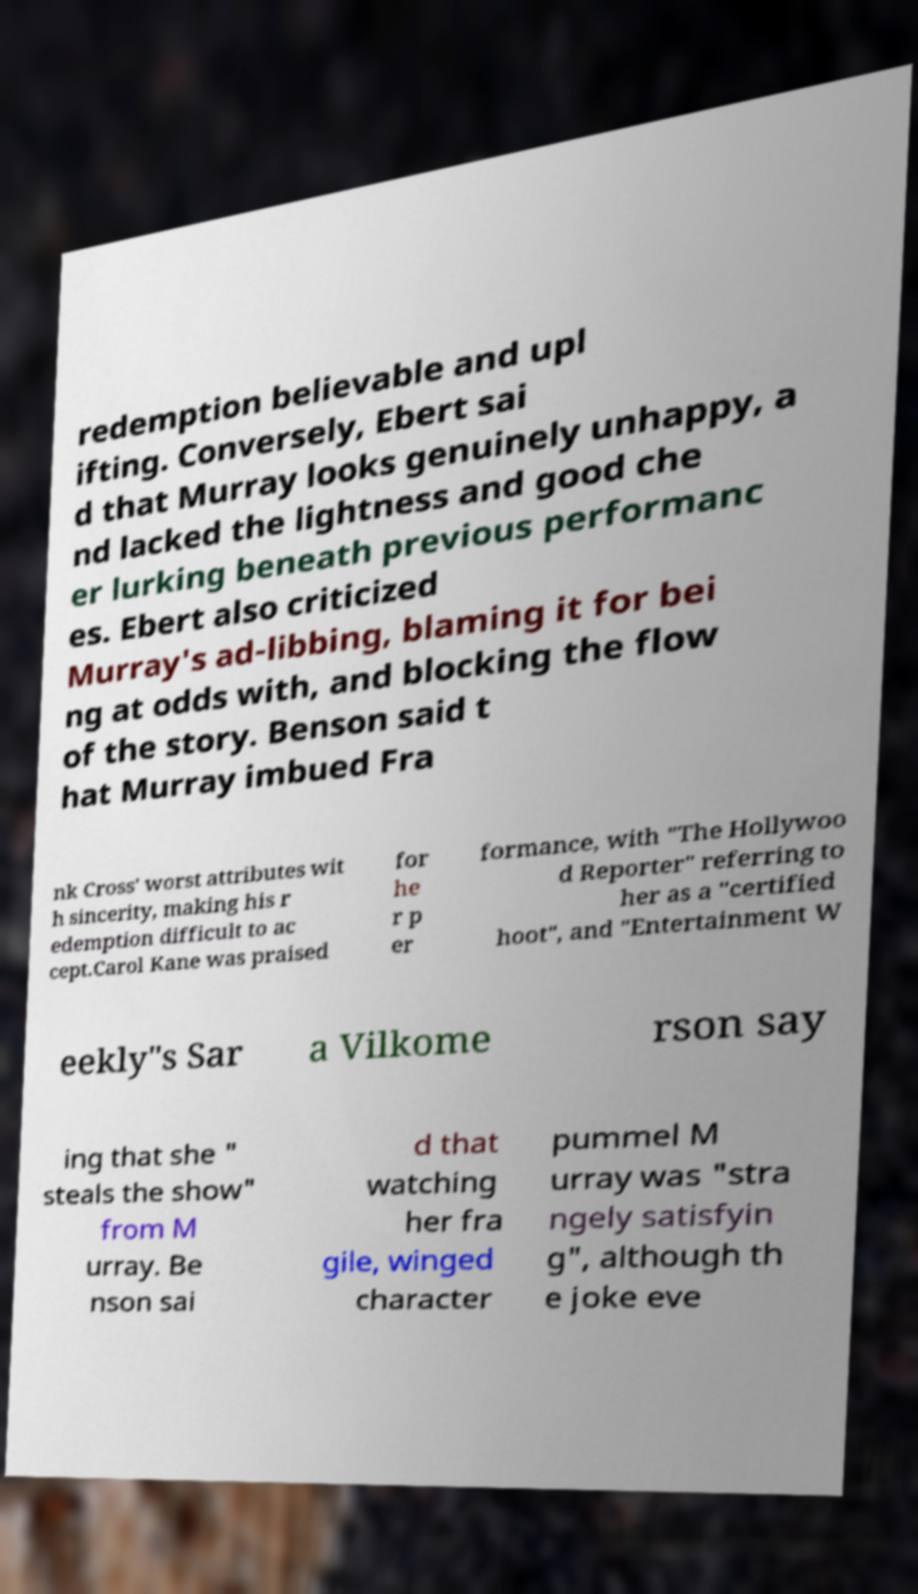Can you accurately transcribe the text from the provided image for me? redemption believable and upl ifting. Conversely, Ebert sai d that Murray looks genuinely unhappy, a nd lacked the lightness and good che er lurking beneath previous performanc es. Ebert also criticized Murray's ad-libbing, blaming it for bei ng at odds with, and blocking the flow of the story. Benson said t hat Murray imbued Fra nk Cross' worst attributes wit h sincerity, making his r edemption difficult to ac cept.Carol Kane was praised for he r p er formance, with "The Hollywoo d Reporter" referring to her as a "certified hoot", and "Entertainment W eekly"s Sar a Vilkome rson say ing that she " steals the show" from M urray. Be nson sai d that watching her fra gile, winged character pummel M urray was "stra ngely satisfyin g", although th e joke eve 